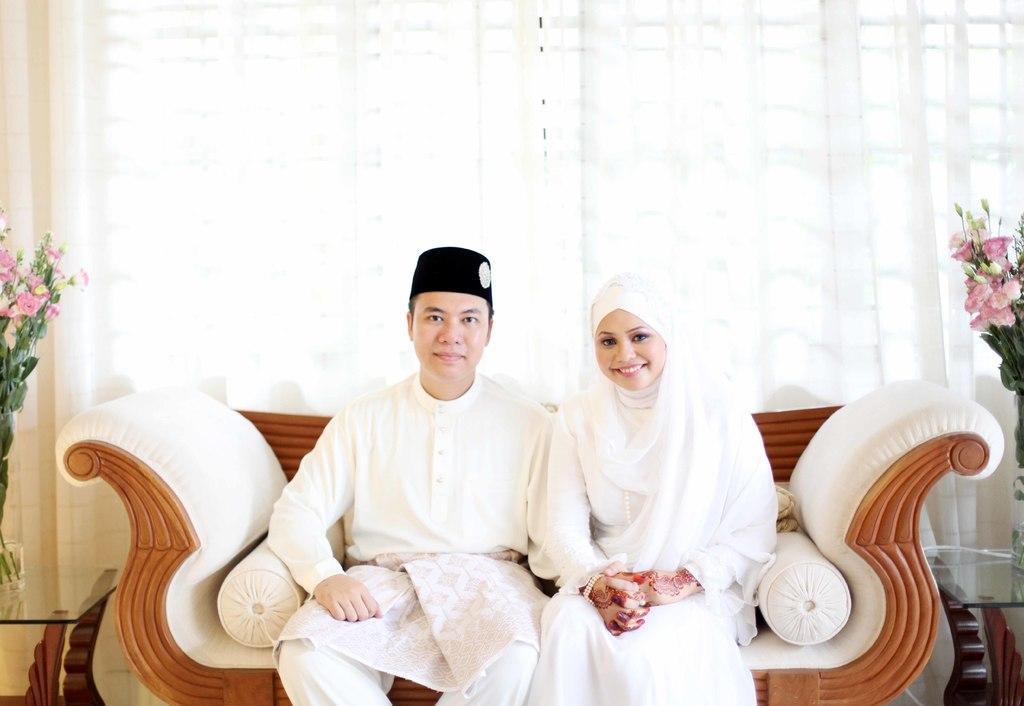Describe this image in one or two sentences. In this image in the center there are two persons sitting on a couch, and on the couch there are pillows. And on the right side and left side there are some plants and flowers and tables, in the background there is a window and curtains. 